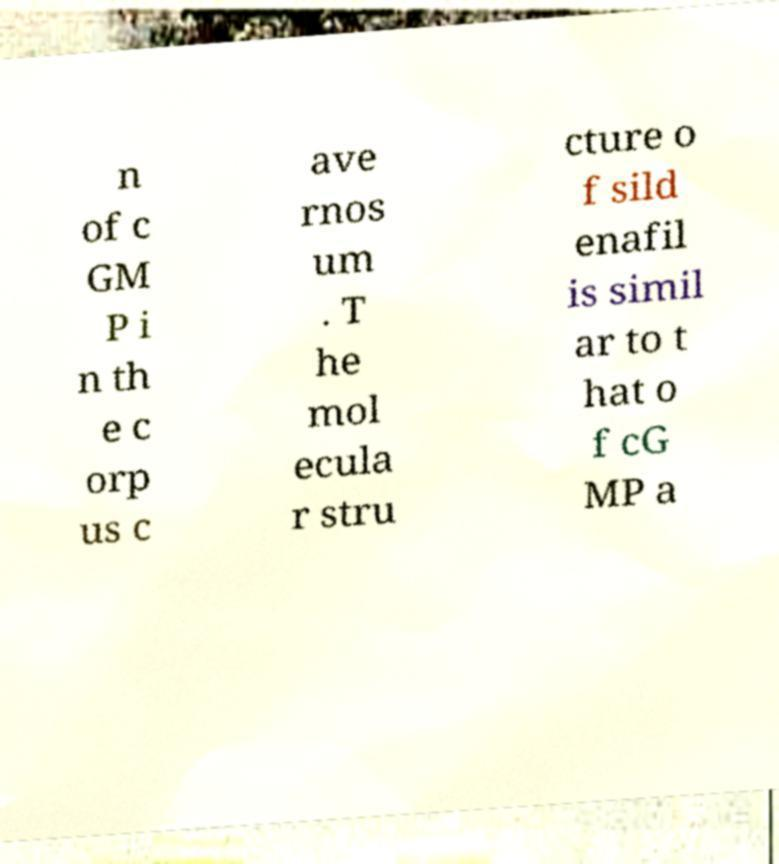Can you accurately transcribe the text from the provided image for me? n of c GM P i n th e c orp us c ave rnos um . T he mol ecula r stru cture o f sild enafil is simil ar to t hat o f cG MP a 